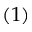Convert formula to latex. <formula><loc_0><loc_0><loc_500><loc_500>( 1 )</formula> 